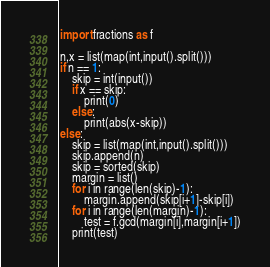<code> <loc_0><loc_0><loc_500><loc_500><_Python_>import fractions as f

n,x = list(map(int,input().split()))
if n == 1:
    skip = int(input())
    if x == skip:
        print(0)
    else:
        print(abs(x-skip))
else:
    skip = list(map(int,input().split()))
    skip.append(n)
    skip = sorted(skip)
    margin = list()
    for i in range(len(skip)-1):
        margin.append(skip[i+1]-skip[i])
    for i in range(len(margin)-1):
        test = f.gcd(margin[i],margin[i+1])
    print(test)</code> 